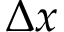<formula> <loc_0><loc_0><loc_500><loc_500>\Delta x</formula> 